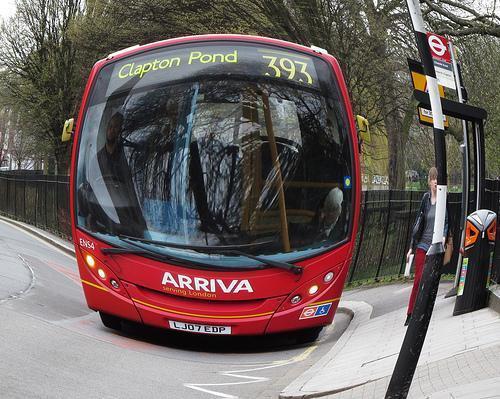How many people are in the photo?
Give a very brief answer. 1. How many pedestrians are crossing the road?
Give a very brief answer. 0. 